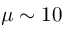Convert formula to latex. <formula><loc_0><loc_0><loc_500><loc_500>\mu \sim 1 0</formula> 